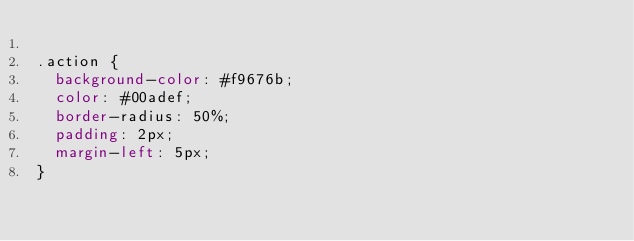Convert code to text. <code><loc_0><loc_0><loc_500><loc_500><_CSS_>
.action {
  background-color: #f9676b;
  color: #00adef;
  border-radius: 50%;
  padding: 2px;
  margin-left: 5px;
}
</code> 